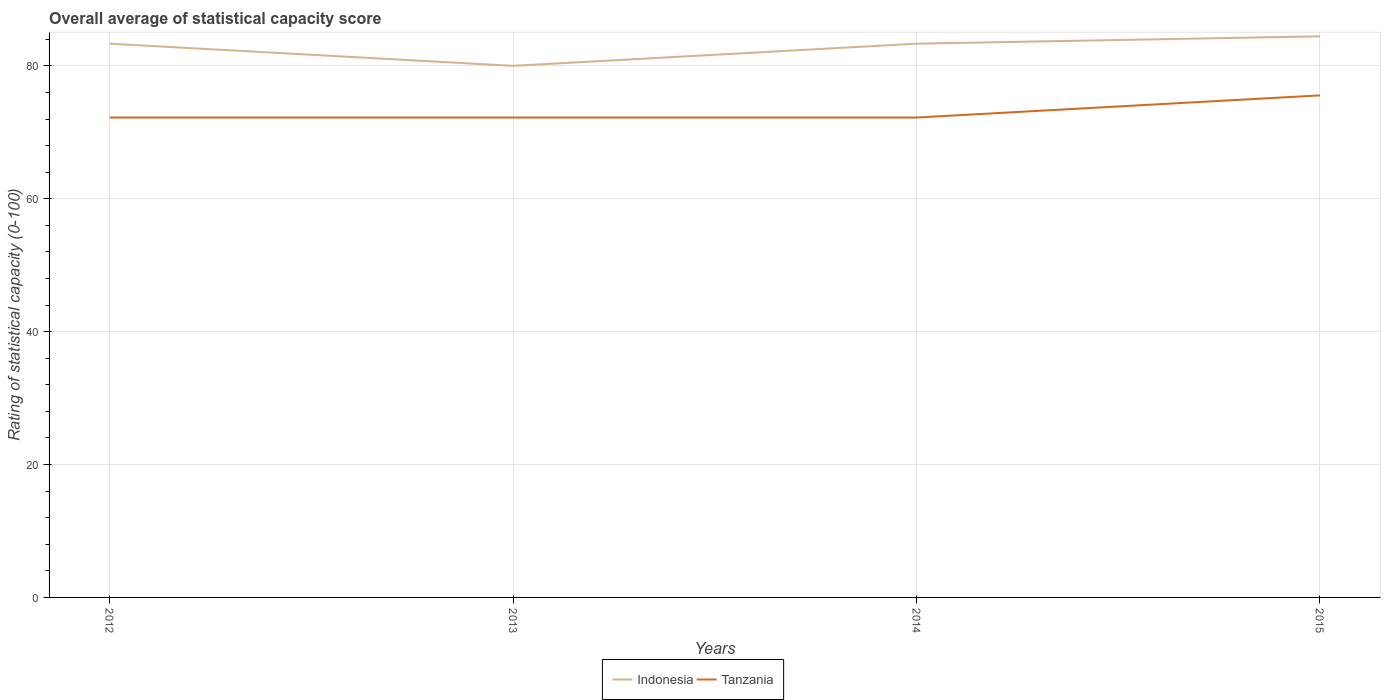Does the line corresponding to Indonesia intersect with the line corresponding to Tanzania?
Your answer should be compact. No. Across all years, what is the maximum rating of statistical capacity in Tanzania?
Keep it short and to the point. 72.22. In which year was the rating of statistical capacity in Indonesia maximum?
Keep it short and to the point. 2013. What is the difference between the highest and the second highest rating of statistical capacity in Tanzania?
Make the answer very short. 3.33. Is the rating of statistical capacity in Tanzania strictly greater than the rating of statistical capacity in Indonesia over the years?
Keep it short and to the point. Yes. How many lines are there?
Provide a short and direct response. 2. How many years are there in the graph?
Your response must be concise. 4. What is the difference between two consecutive major ticks on the Y-axis?
Give a very brief answer. 20. Does the graph contain any zero values?
Offer a very short reply. No. Does the graph contain grids?
Your response must be concise. Yes. How many legend labels are there?
Your response must be concise. 2. How are the legend labels stacked?
Offer a terse response. Horizontal. What is the title of the graph?
Make the answer very short. Overall average of statistical capacity score. Does "Guatemala" appear as one of the legend labels in the graph?
Make the answer very short. No. What is the label or title of the Y-axis?
Keep it short and to the point. Rating of statistical capacity (0-100). What is the Rating of statistical capacity (0-100) in Indonesia in 2012?
Ensure brevity in your answer.  83.33. What is the Rating of statistical capacity (0-100) in Tanzania in 2012?
Your answer should be very brief. 72.22. What is the Rating of statistical capacity (0-100) in Tanzania in 2013?
Provide a short and direct response. 72.22. What is the Rating of statistical capacity (0-100) in Indonesia in 2014?
Ensure brevity in your answer.  83.33. What is the Rating of statistical capacity (0-100) in Tanzania in 2014?
Offer a terse response. 72.22. What is the Rating of statistical capacity (0-100) of Indonesia in 2015?
Your response must be concise. 84.44. What is the Rating of statistical capacity (0-100) in Tanzania in 2015?
Ensure brevity in your answer.  75.56. Across all years, what is the maximum Rating of statistical capacity (0-100) in Indonesia?
Your response must be concise. 84.44. Across all years, what is the maximum Rating of statistical capacity (0-100) in Tanzania?
Your answer should be very brief. 75.56. Across all years, what is the minimum Rating of statistical capacity (0-100) of Tanzania?
Your response must be concise. 72.22. What is the total Rating of statistical capacity (0-100) of Indonesia in the graph?
Keep it short and to the point. 331.11. What is the total Rating of statistical capacity (0-100) in Tanzania in the graph?
Your answer should be very brief. 292.22. What is the difference between the Rating of statistical capacity (0-100) in Tanzania in 2012 and that in 2014?
Ensure brevity in your answer.  0. What is the difference between the Rating of statistical capacity (0-100) of Indonesia in 2012 and that in 2015?
Give a very brief answer. -1.11. What is the difference between the Rating of statistical capacity (0-100) of Tanzania in 2012 and that in 2015?
Provide a succinct answer. -3.33. What is the difference between the Rating of statistical capacity (0-100) in Indonesia in 2013 and that in 2015?
Provide a short and direct response. -4.44. What is the difference between the Rating of statistical capacity (0-100) in Tanzania in 2013 and that in 2015?
Your answer should be compact. -3.33. What is the difference between the Rating of statistical capacity (0-100) in Indonesia in 2014 and that in 2015?
Provide a succinct answer. -1.11. What is the difference between the Rating of statistical capacity (0-100) in Tanzania in 2014 and that in 2015?
Offer a very short reply. -3.33. What is the difference between the Rating of statistical capacity (0-100) of Indonesia in 2012 and the Rating of statistical capacity (0-100) of Tanzania in 2013?
Provide a short and direct response. 11.11. What is the difference between the Rating of statistical capacity (0-100) of Indonesia in 2012 and the Rating of statistical capacity (0-100) of Tanzania in 2014?
Provide a short and direct response. 11.11. What is the difference between the Rating of statistical capacity (0-100) of Indonesia in 2012 and the Rating of statistical capacity (0-100) of Tanzania in 2015?
Offer a terse response. 7.78. What is the difference between the Rating of statistical capacity (0-100) in Indonesia in 2013 and the Rating of statistical capacity (0-100) in Tanzania in 2014?
Your answer should be very brief. 7.78. What is the difference between the Rating of statistical capacity (0-100) of Indonesia in 2013 and the Rating of statistical capacity (0-100) of Tanzania in 2015?
Provide a short and direct response. 4.44. What is the difference between the Rating of statistical capacity (0-100) of Indonesia in 2014 and the Rating of statistical capacity (0-100) of Tanzania in 2015?
Offer a very short reply. 7.78. What is the average Rating of statistical capacity (0-100) in Indonesia per year?
Offer a terse response. 82.78. What is the average Rating of statistical capacity (0-100) of Tanzania per year?
Provide a short and direct response. 73.06. In the year 2012, what is the difference between the Rating of statistical capacity (0-100) of Indonesia and Rating of statistical capacity (0-100) of Tanzania?
Your answer should be very brief. 11.11. In the year 2013, what is the difference between the Rating of statistical capacity (0-100) in Indonesia and Rating of statistical capacity (0-100) in Tanzania?
Make the answer very short. 7.78. In the year 2014, what is the difference between the Rating of statistical capacity (0-100) in Indonesia and Rating of statistical capacity (0-100) in Tanzania?
Your answer should be very brief. 11.11. In the year 2015, what is the difference between the Rating of statistical capacity (0-100) of Indonesia and Rating of statistical capacity (0-100) of Tanzania?
Your answer should be compact. 8.89. What is the ratio of the Rating of statistical capacity (0-100) in Indonesia in 2012 to that in 2013?
Provide a short and direct response. 1.04. What is the ratio of the Rating of statistical capacity (0-100) in Tanzania in 2012 to that in 2013?
Make the answer very short. 1. What is the ratio of the Rating of statistical capacity (0-100) of Indonesia in 2012 to that in 2014?
Your answer should be compact. 1. What is the ratio of the Rating of statistical capacity (0-100) in Tanzania in 2012 to that in 2015?
Your answer should be very brief. 0.96. What is the ratio of the Rating of statistical capacity (0-100) of Indonesia in 2013 to that in 2014?
Provide a succinct answer. 0.96. What is the ratio of the Rating of statistical capacity (0-100) in Tanzania in 2013 to that in 2014?
Your answer should be compact. 1. What is the ratio of the Rating of statistical capacity (0-100) of Indonesia in 2013 to that in 2015?
Provide a succinct answer. 0.95. What is the ratio of the Rating of statistical capacity (0-100) in Tanzania in 2013 to that in 2015?
Ensure brevity in your answer.  0.96. What is the ratio of the Rating of statistical capacity (0-100) in Tanzania in 2014 to that in 2015?
Provide a succinct answer. 0.96. What is the difference between the highest and the second highest Rating of statistical capacity (0-100) of Indonesia?
Ensure brevity in your answer.  1.11. What is the difference between the highest and the second highest Rating of statistical capacity (0-100) of Tanzania?
Give a very brief answer. 3.33. What is the difference between the highest and the lowest Rating of statistical capacity (0-100) of Indonesia?
Make the answer very short. 4.44. What is the difference between the highest and the lowest Rating of statistical capacity (0-100) of Tanzania?
Offer a very short reply. 3.33. 